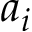Convert formula to latex. <formula><loc_0><loc_0><loc_500><loc_500>a _ { i }</formula> 